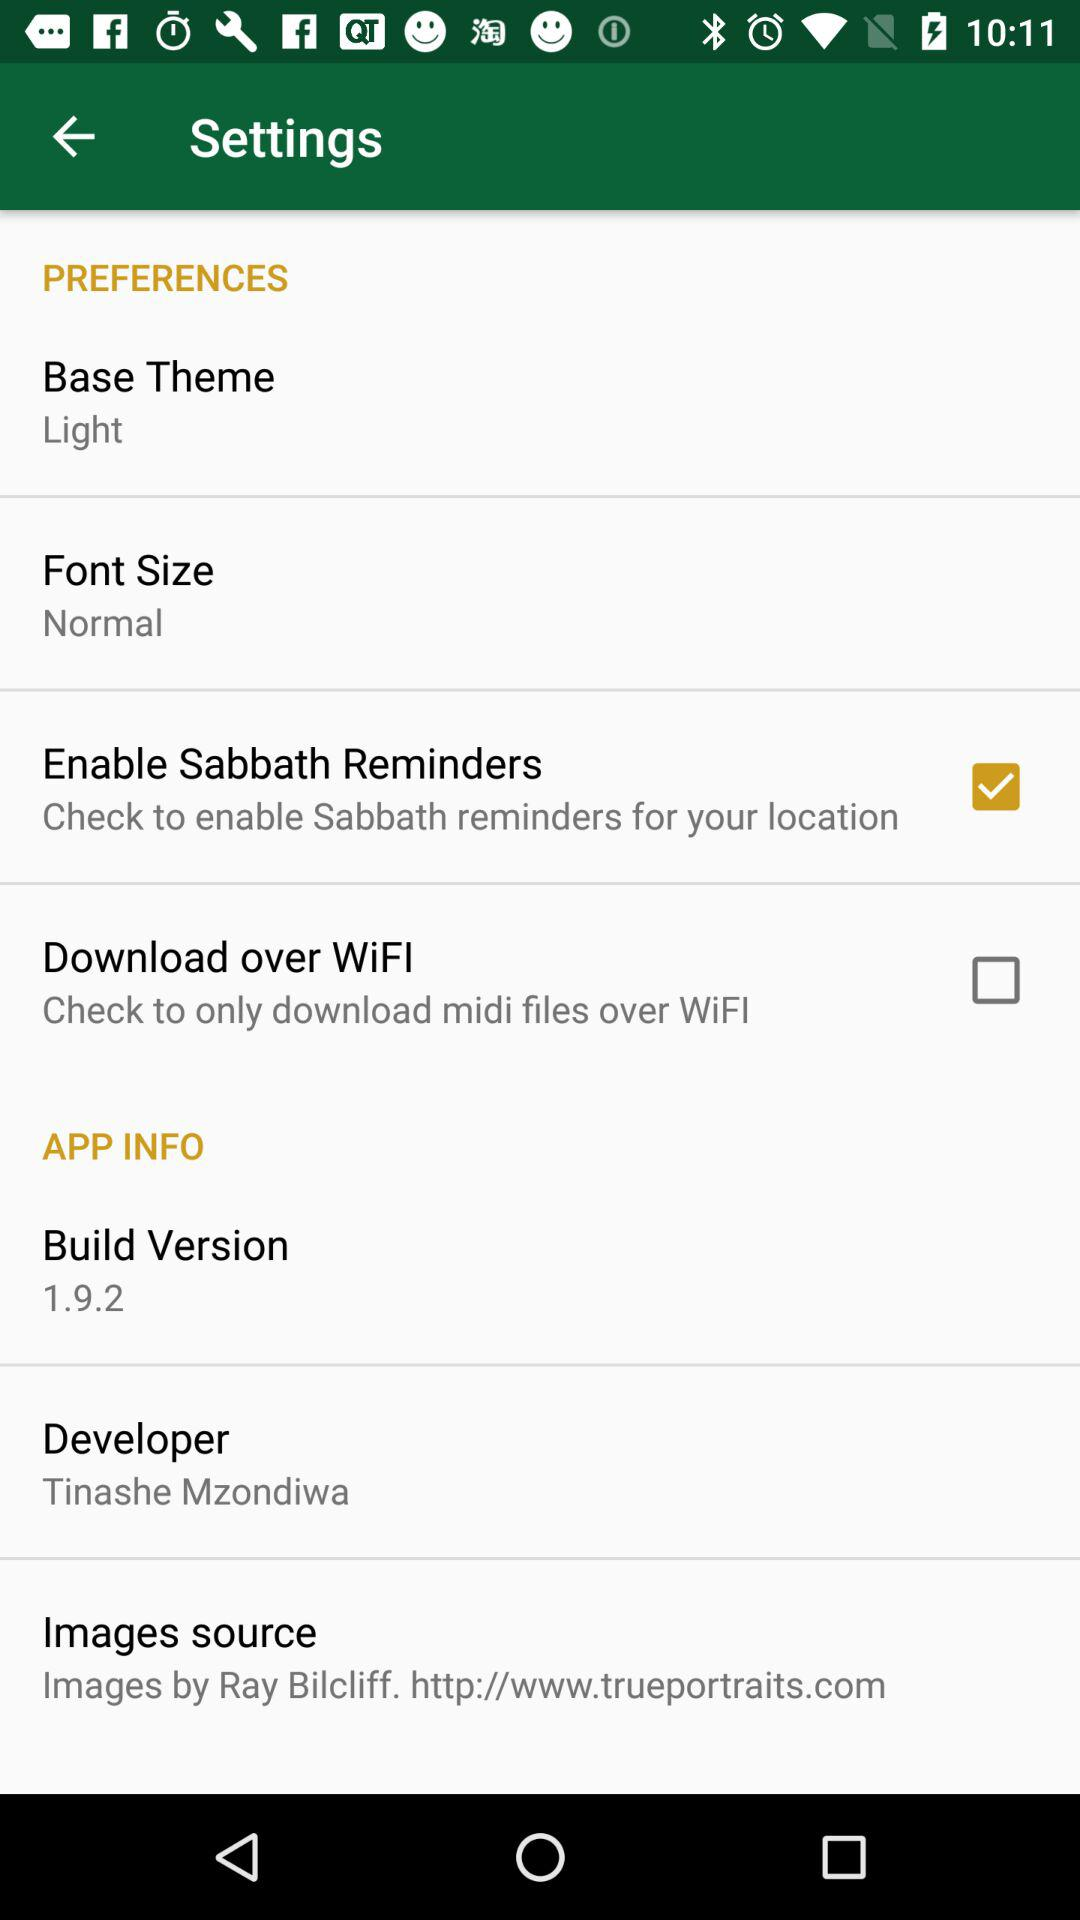What is the base theme? The base theme is light. 